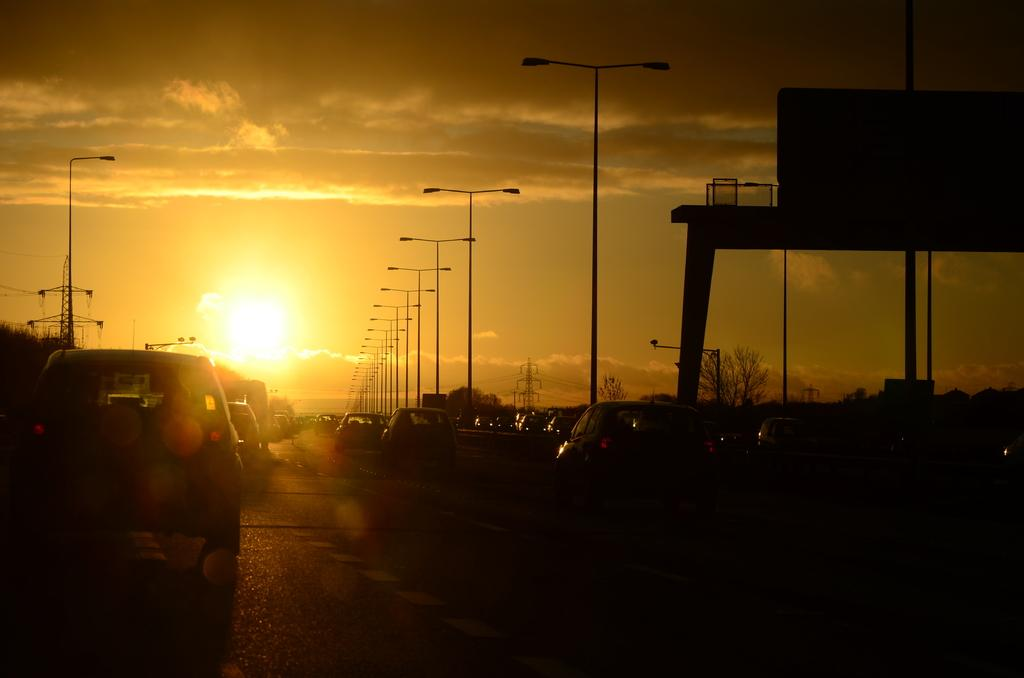What can be seen on the road in the image? There are vehicles on the road in the image. What structures are present alongside the road? There are light poles in the image. What type of vegetation is visible in the image? There are trees in the image. What tall structures can be seen in the image? There are towers in the image. What else is present in the image besides the mentioned elements? There are objects in the image. What is visible in the background of the image? The sky is visible in the background of the image. What can be observed in the sky? Clouds are present in the sky. What type of plantation is visible in the image? There is no plantation present in the image. Can you tell me the statement made by the vehicles on the road? Vehicles do not make statements in the image; they are simply moving or stationary objects. 